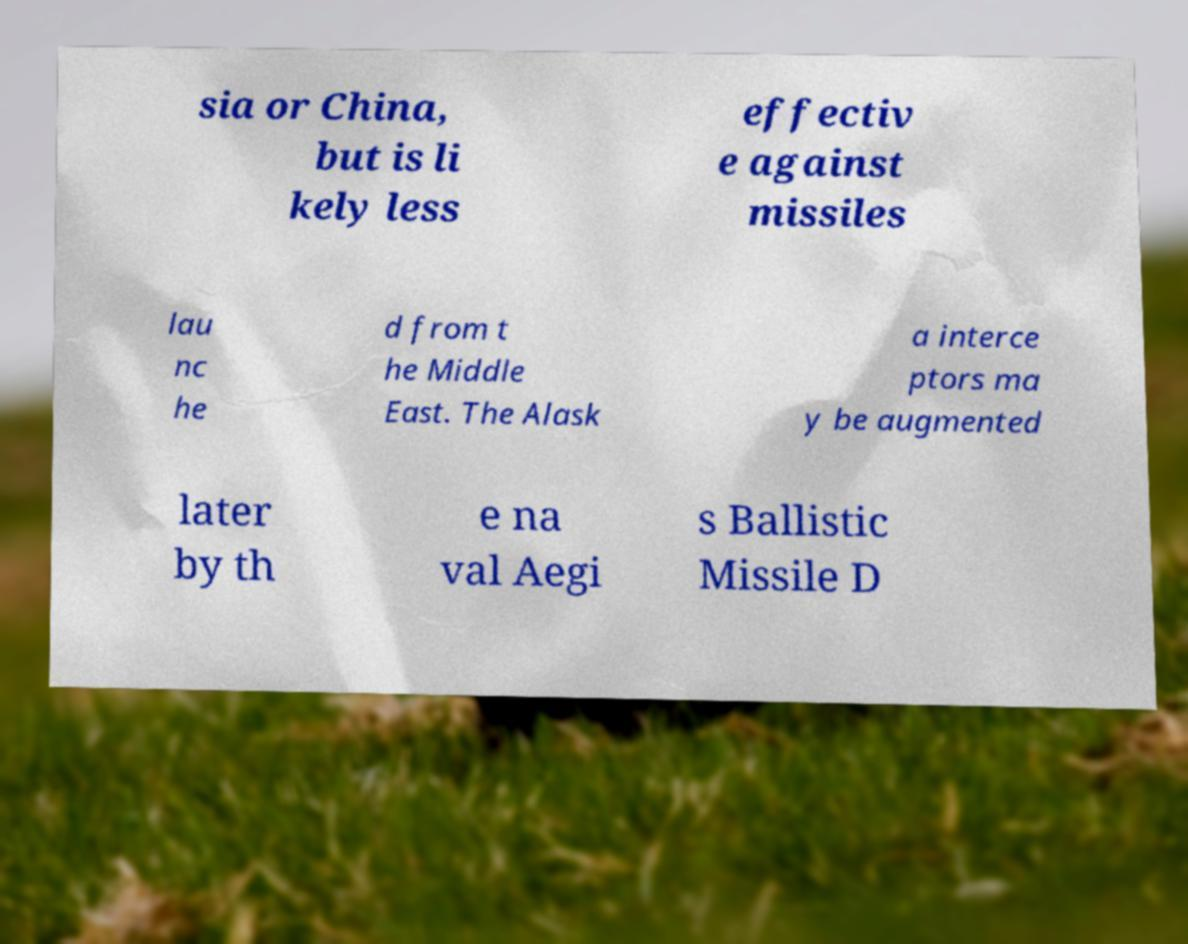For documentation purposes, I need the text within this image transcribed. Could you provide that? sia or China, but is li kely less effectiv e against missiles lau nc he d from t he Middle East. The Alask a interce ptors ma y be augmented later by th e na val Aegi s Ballistic Missile D 